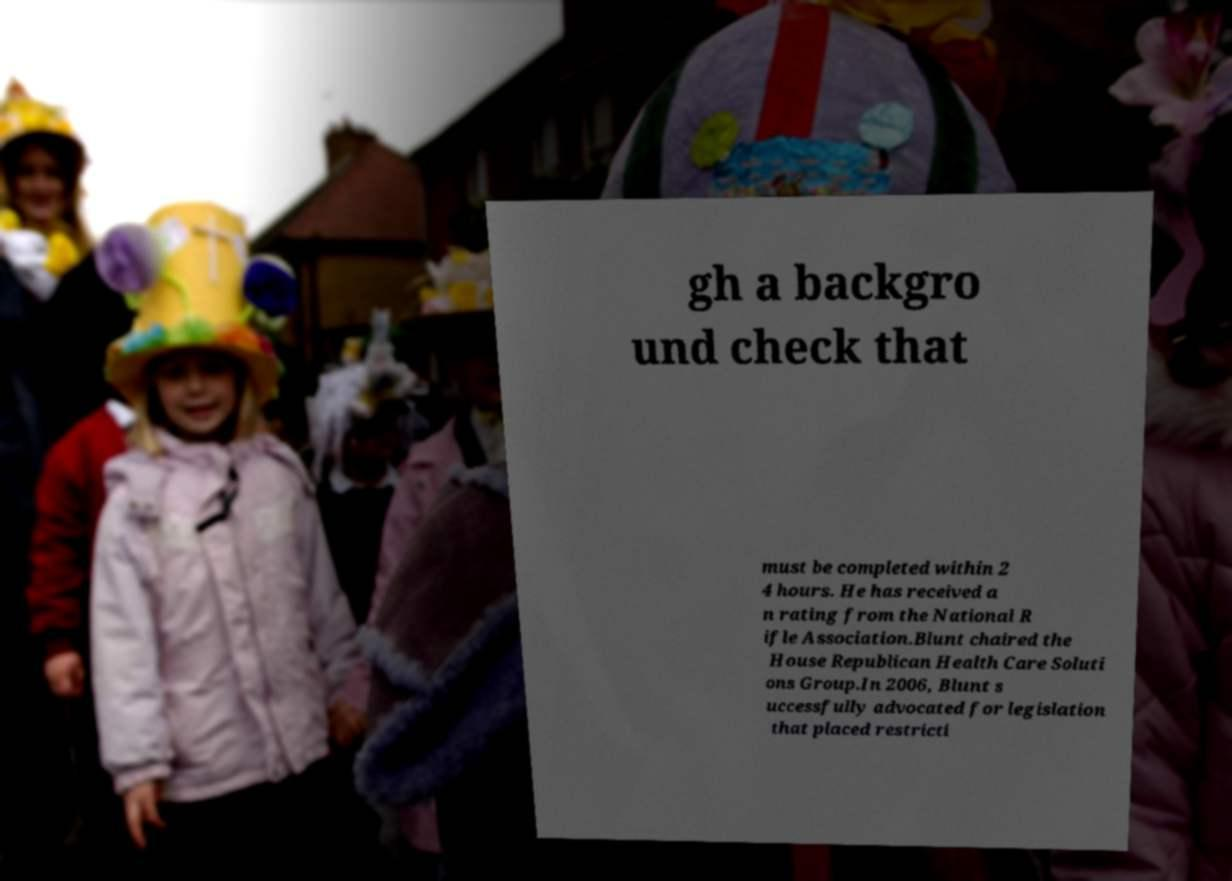Please read and relay the text visible in this image. What does it say? gh a backgro und check that must be completed within 2 4 hours. He has received a n rating from the National R ifle Association.Blunt chaired the House Republican Health Care Soluti ons Group.In 2006, Blunt s uccessfully advocated for legislation that placed restricti 